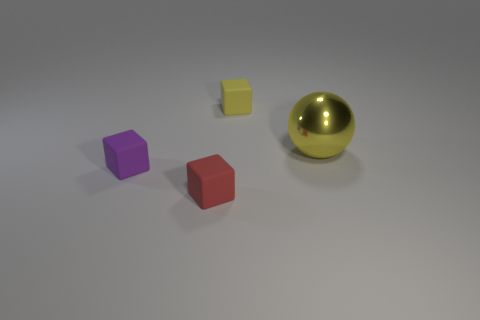Subtract 1 cubes. How many cubes are left? 2 Add 2 red rubber objects. How many objects exist? 6 Subtract all spheres. How many objects are left? 3 Add 2 tiny gray rubber blocks. How many tiny gray rubber blocks exist? 2 Subtract 0 cyan spheres. How many objects are left? 4 Subtract all small blocks. Subtract all red things. How many objects are left? 0 Add 2 spheres. How many spheres are left? 3 